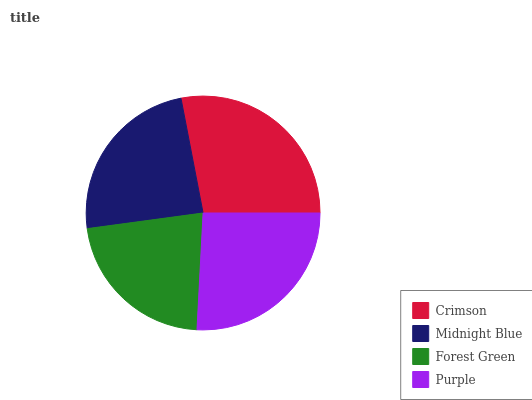Is Forest Green the minimum?
Answer yes or no. Yes. Is Crimson the maximum?
Answer yes or no. Yes. Is Midnight Blue the minimum?
Answer yes or no. No. Is Midnight Blue the maximum?
Answer yes or no. No. Is Crimson greater than Midnight Blue?
Answer yes or no. Yes. Is Midnight Blue less than Crimson?
Answer yes or no. Yes. Is Midnight Blue greater than Crimson?
Answer yes or no. No. Is Crimson less than Midnight Blue?
Answer yes or no. No. Is Purple the high median?
Answer yes or no. Yes. Is Midnight Blue the low median?
Answer yes or no. Yes. Is Forest Green the high median?
Answer yes or no. No. Is Crimson the low median?
Answer yes or no. No. 